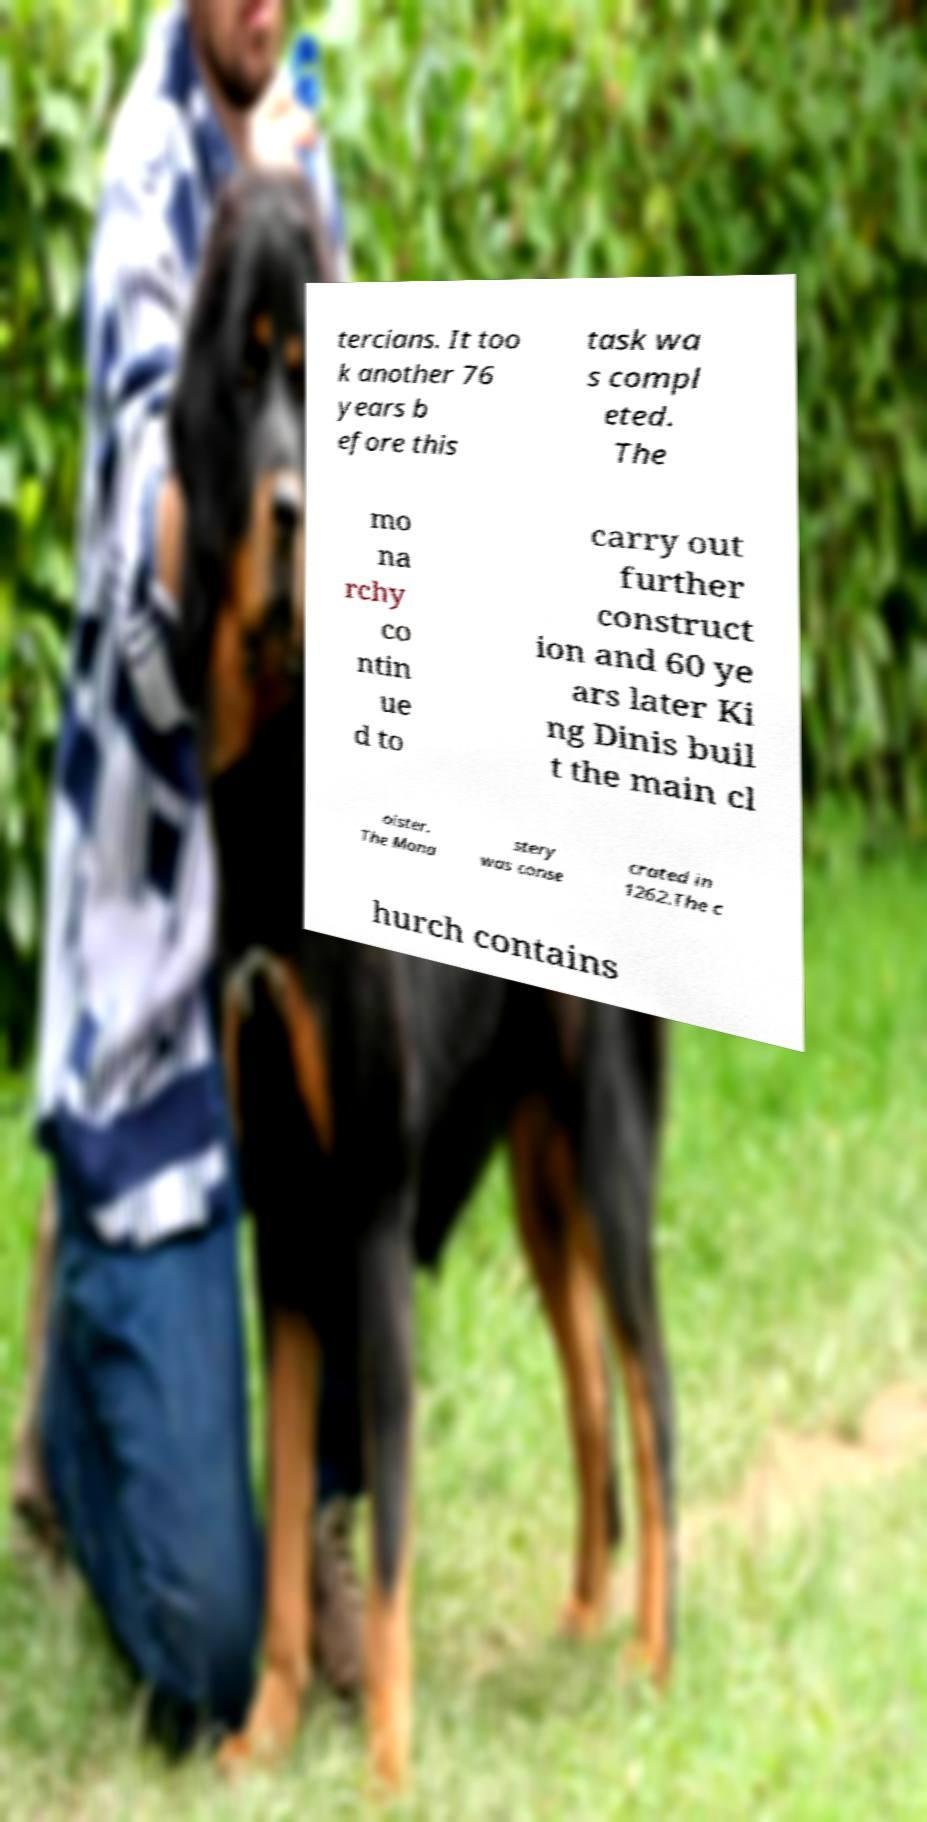For documentation purposes, I need the text within this image transcribed. Could you provide that? tercians. It too k another 76 years b efore this task wa s compl eted. The mo na rchy co ntin ue d to carry out further construct ion and 60 ye ars later Ki ng Dinis buil t the main cl oister. The Mona stery was conse crated in 1262.The c hurch contains 